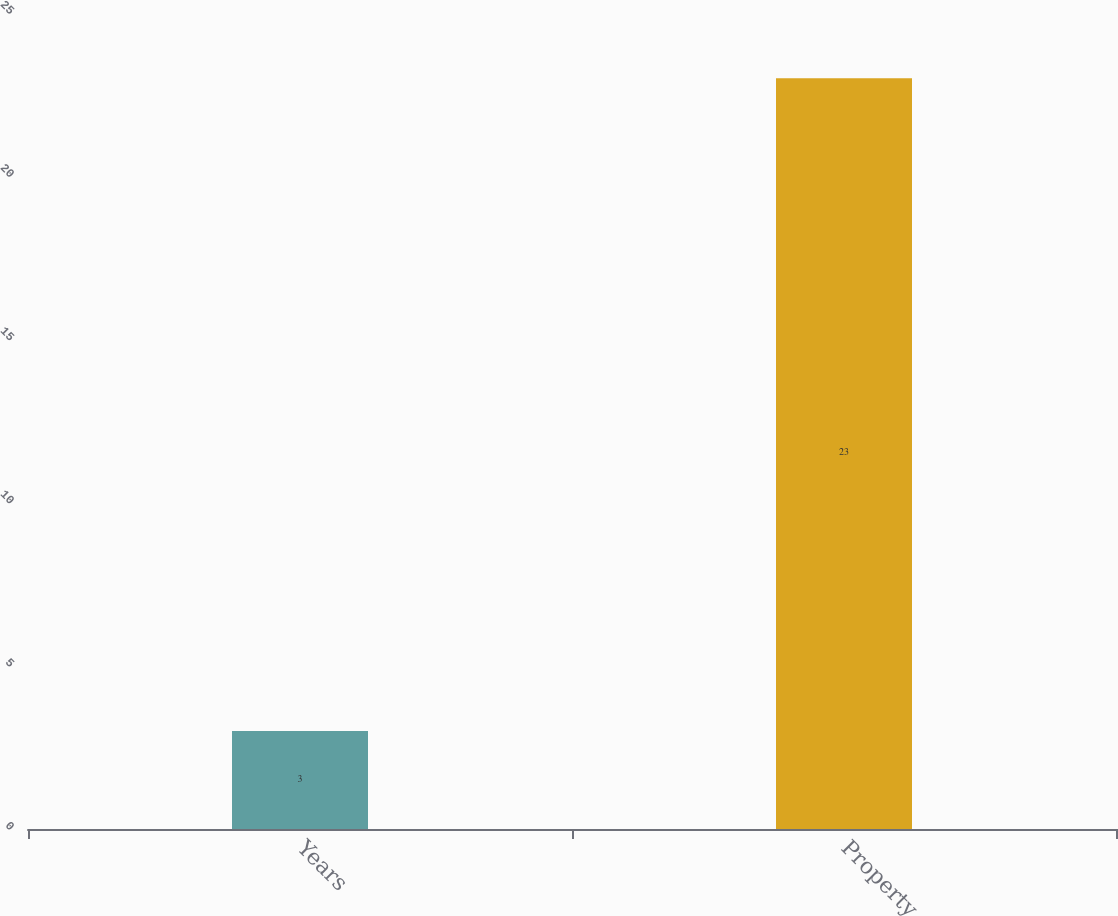<chart> <loc_0><loc_0><loc_500><loc_500><bar_chart><fcel>Years<fcel>Property<nl><fcel>3<fcel>23<nl></chart> 